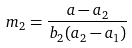<formula> <loc_0><loc_0><loc_500><loc_500>m _ { 2 } = \frac { a - a _ { 2 } } { b _ { 2 } ( a _ { 2 } - a _ { 1 } ) }</formula> 